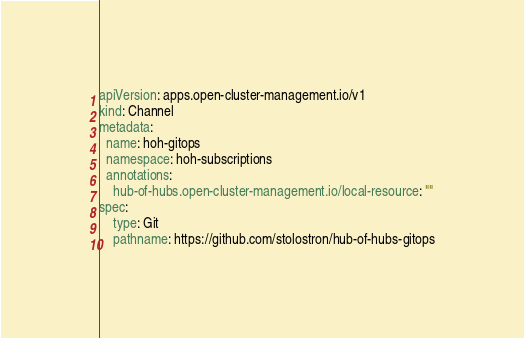<code> <loc_0><loc_0><loc_500><loc_500><_YAML_>apiVersion: apps.open-cluster-management.io/v1
kind: Channel
metadata:
  name: hoh-gitops
  namespace: hoh-subscriptions
  annotations:
    hub-of-hubs.open-cluster-management.io/local-resource: ""
spec:
    type: Git
    pathname: https://github.com/stolostron/hub-of-hubs-gitops</code> 